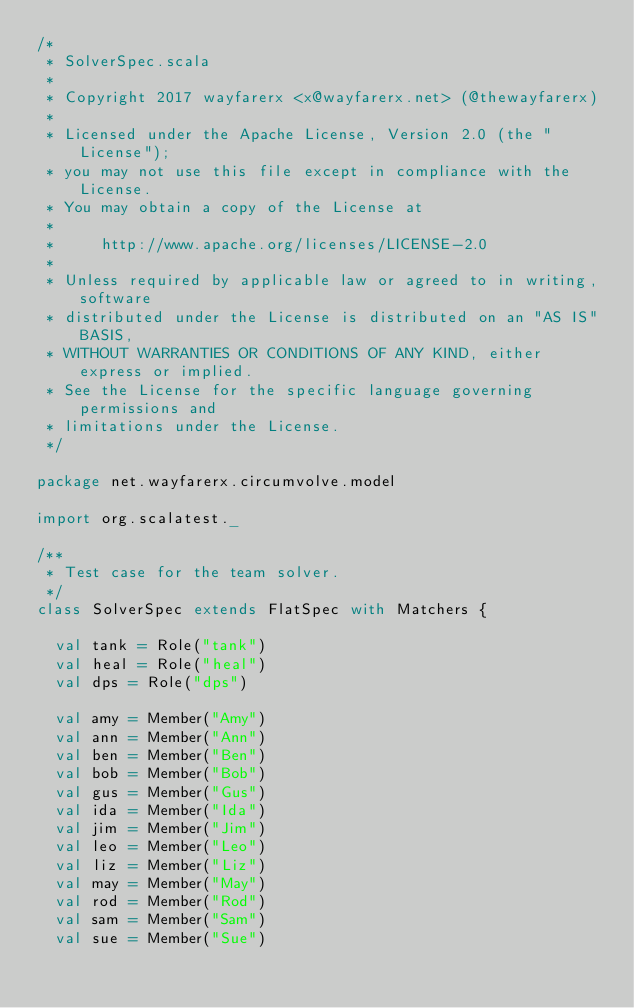<code> <loc_0><loc_0><loc_500><loc_500><_Scala_>/*
 * SolverSpec.scala
 *
 * Copyright 2017 wayfarerx <x@wayfarerx.net> (@thewayfarerx)
 *
 * Licensed under the Apache License, Version 2.0 (the "License");
 * you may not use this file except in compliance with the License.
 * You may obtain a copy of the License at
 *
 *     http://www.apache.org/licenses/LICENSE-2.0
 *
 * Unless required by applicable law or agreed to in writing, software
 * distributed under the License is distributed on an "AS IS" BASIS,
 * WITHOUT WARRANTIES OR CONDITIONS OF ANY KIND, either express or implied.
 * See the License for the specific language governing permissions and
 * limitations under the License.
 */

package net.wayfarerx.circumvolve.model

import org.scalatest._

/**
 * Test case for the team solver.
 */
class SolverSpec extends FlatSpec with Matchers {

  val tank = Role("tank")
  val heal = Role("heal")
  val dps = Role("dps")

  val amy = Member("Amy")
  val ann = Member("Ann")
  val ben = Member("Ben")
  val bob = Member("Bob")
  val gus = Member("Gus")
  val ida = Member("Ida")
  val jim = Member("Jim")
  val leo = Member("Leo")
  val liz = Member("Liz")
  val may = Member("May")
  val rod = Member("Rod")
  val sam = Member("Sam")
  val sue = Member("Sue")</code> 